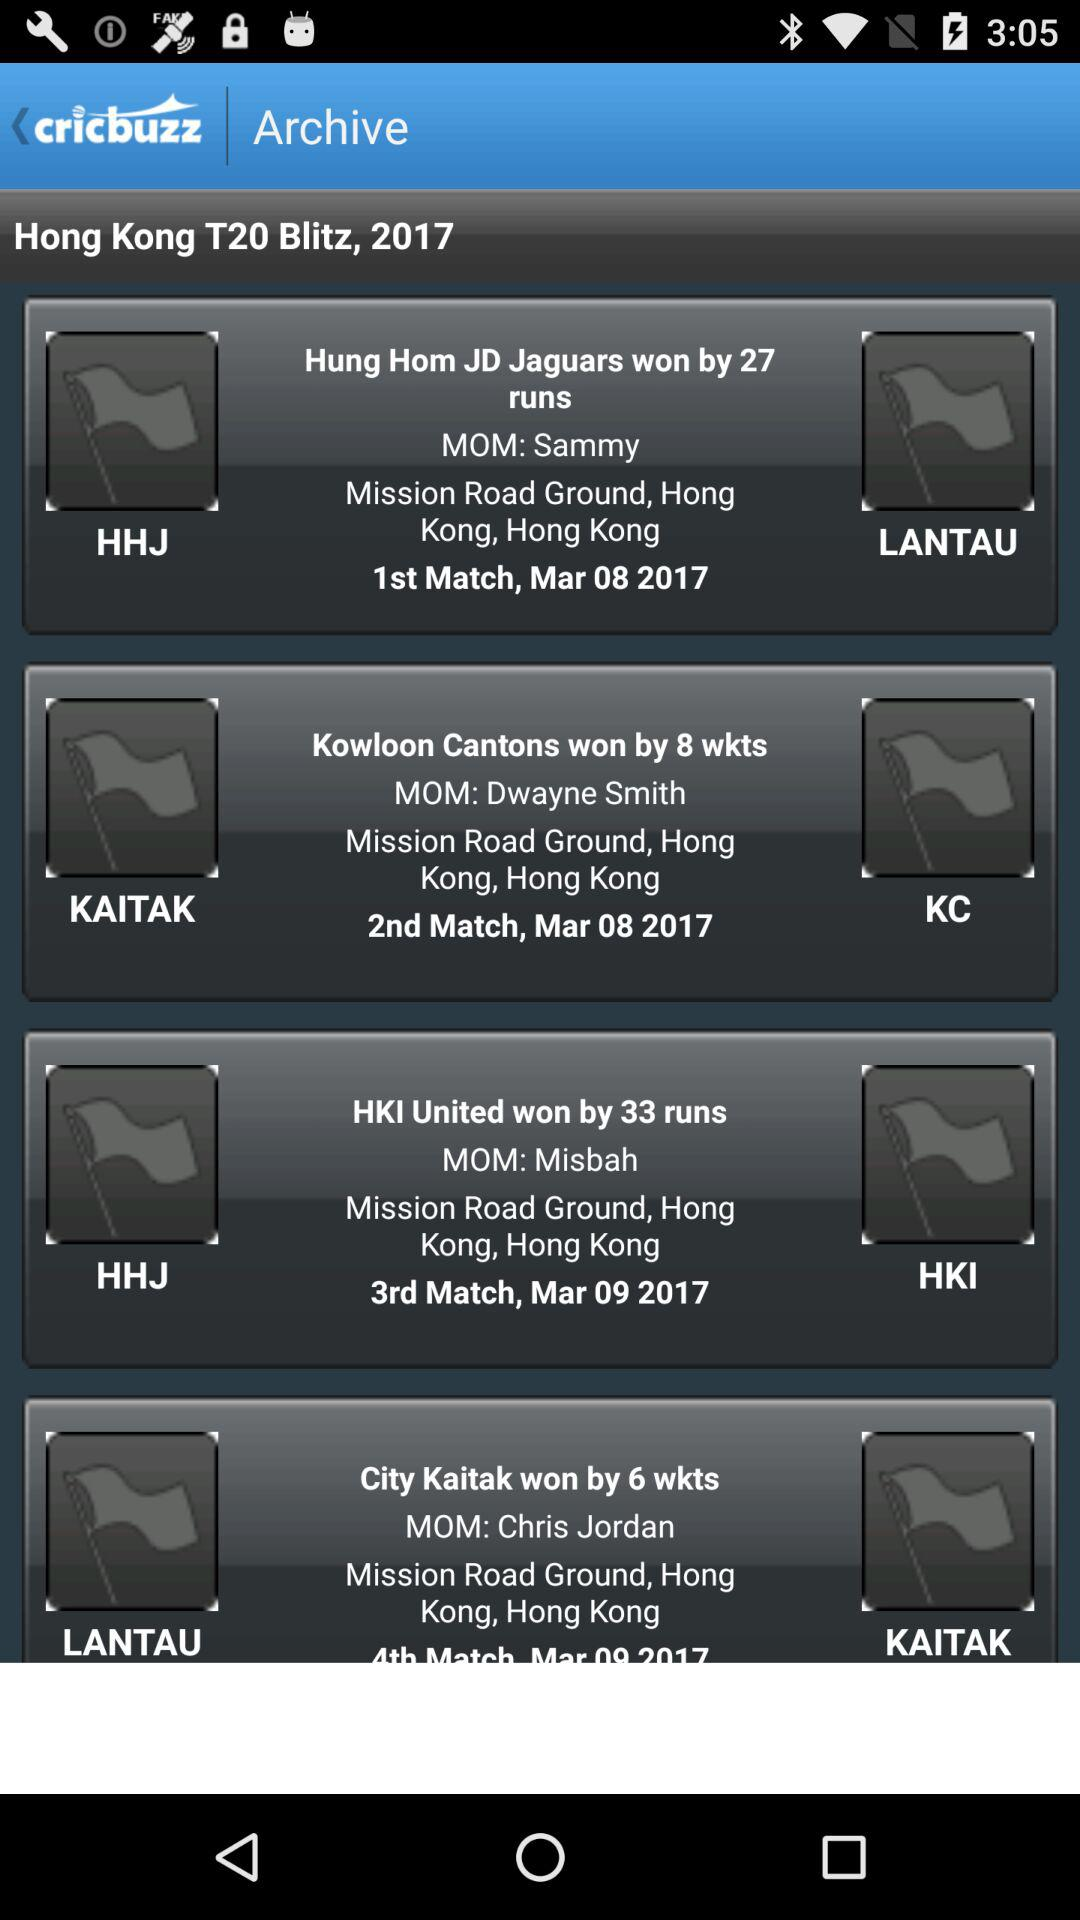On March 9th, 2017, who won the match? The match was won by "HKI United". 